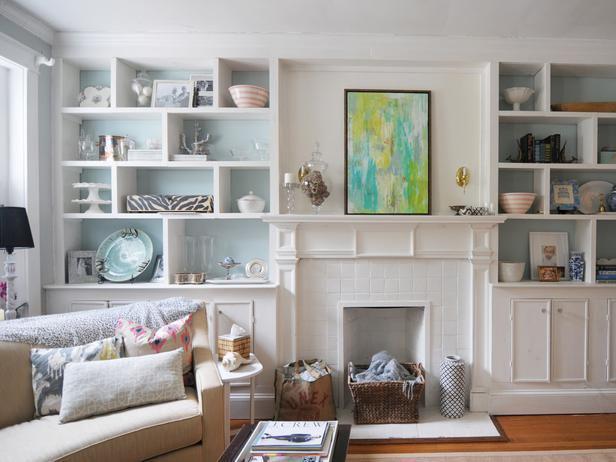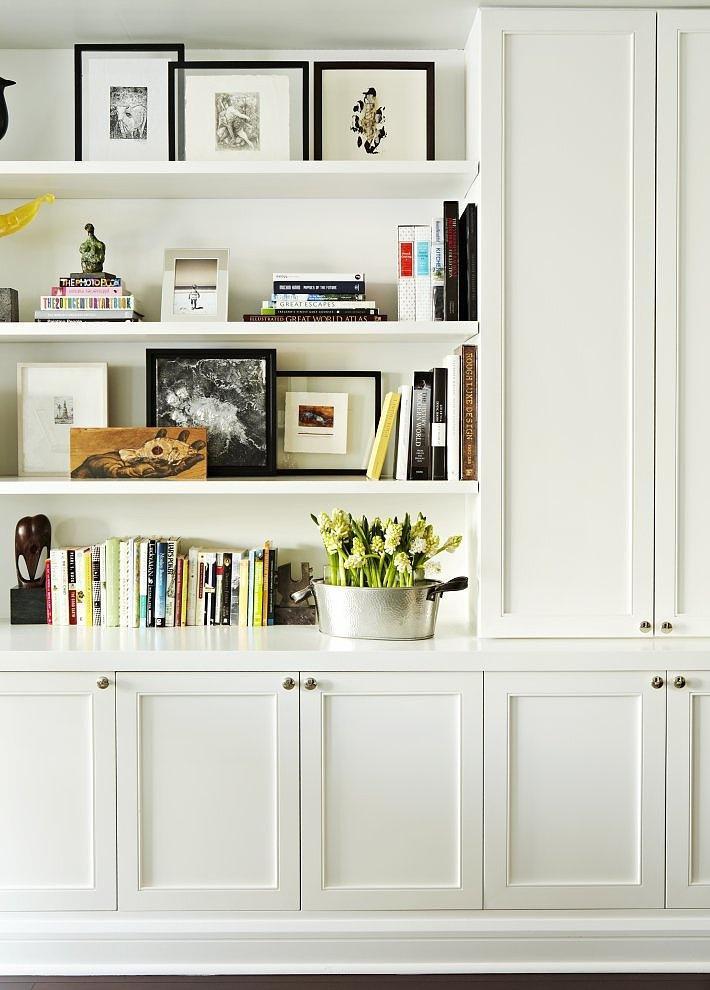The first image is the image on the left, the second image is the image on the right. For the images shown, is this caption "There is a clock on the shelf in the image on the left." true? Answer yes or no. No. 